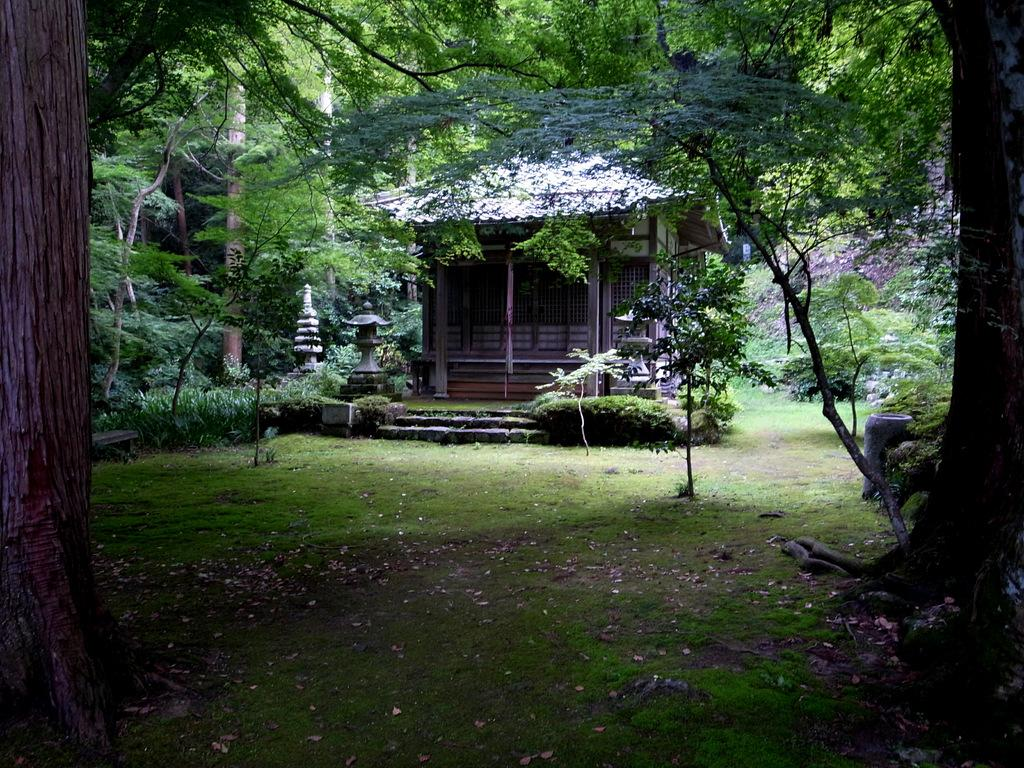What type of vegetation can be seen in the image? There are trees in the image. What type of structure is visible in the image? There is a house in the image. What type of education can be seen in the image? There is no reference to education in the image; it features trees and a house. What type of hat is visible on the trees in the image? There are no hats present on the trees in the image. 